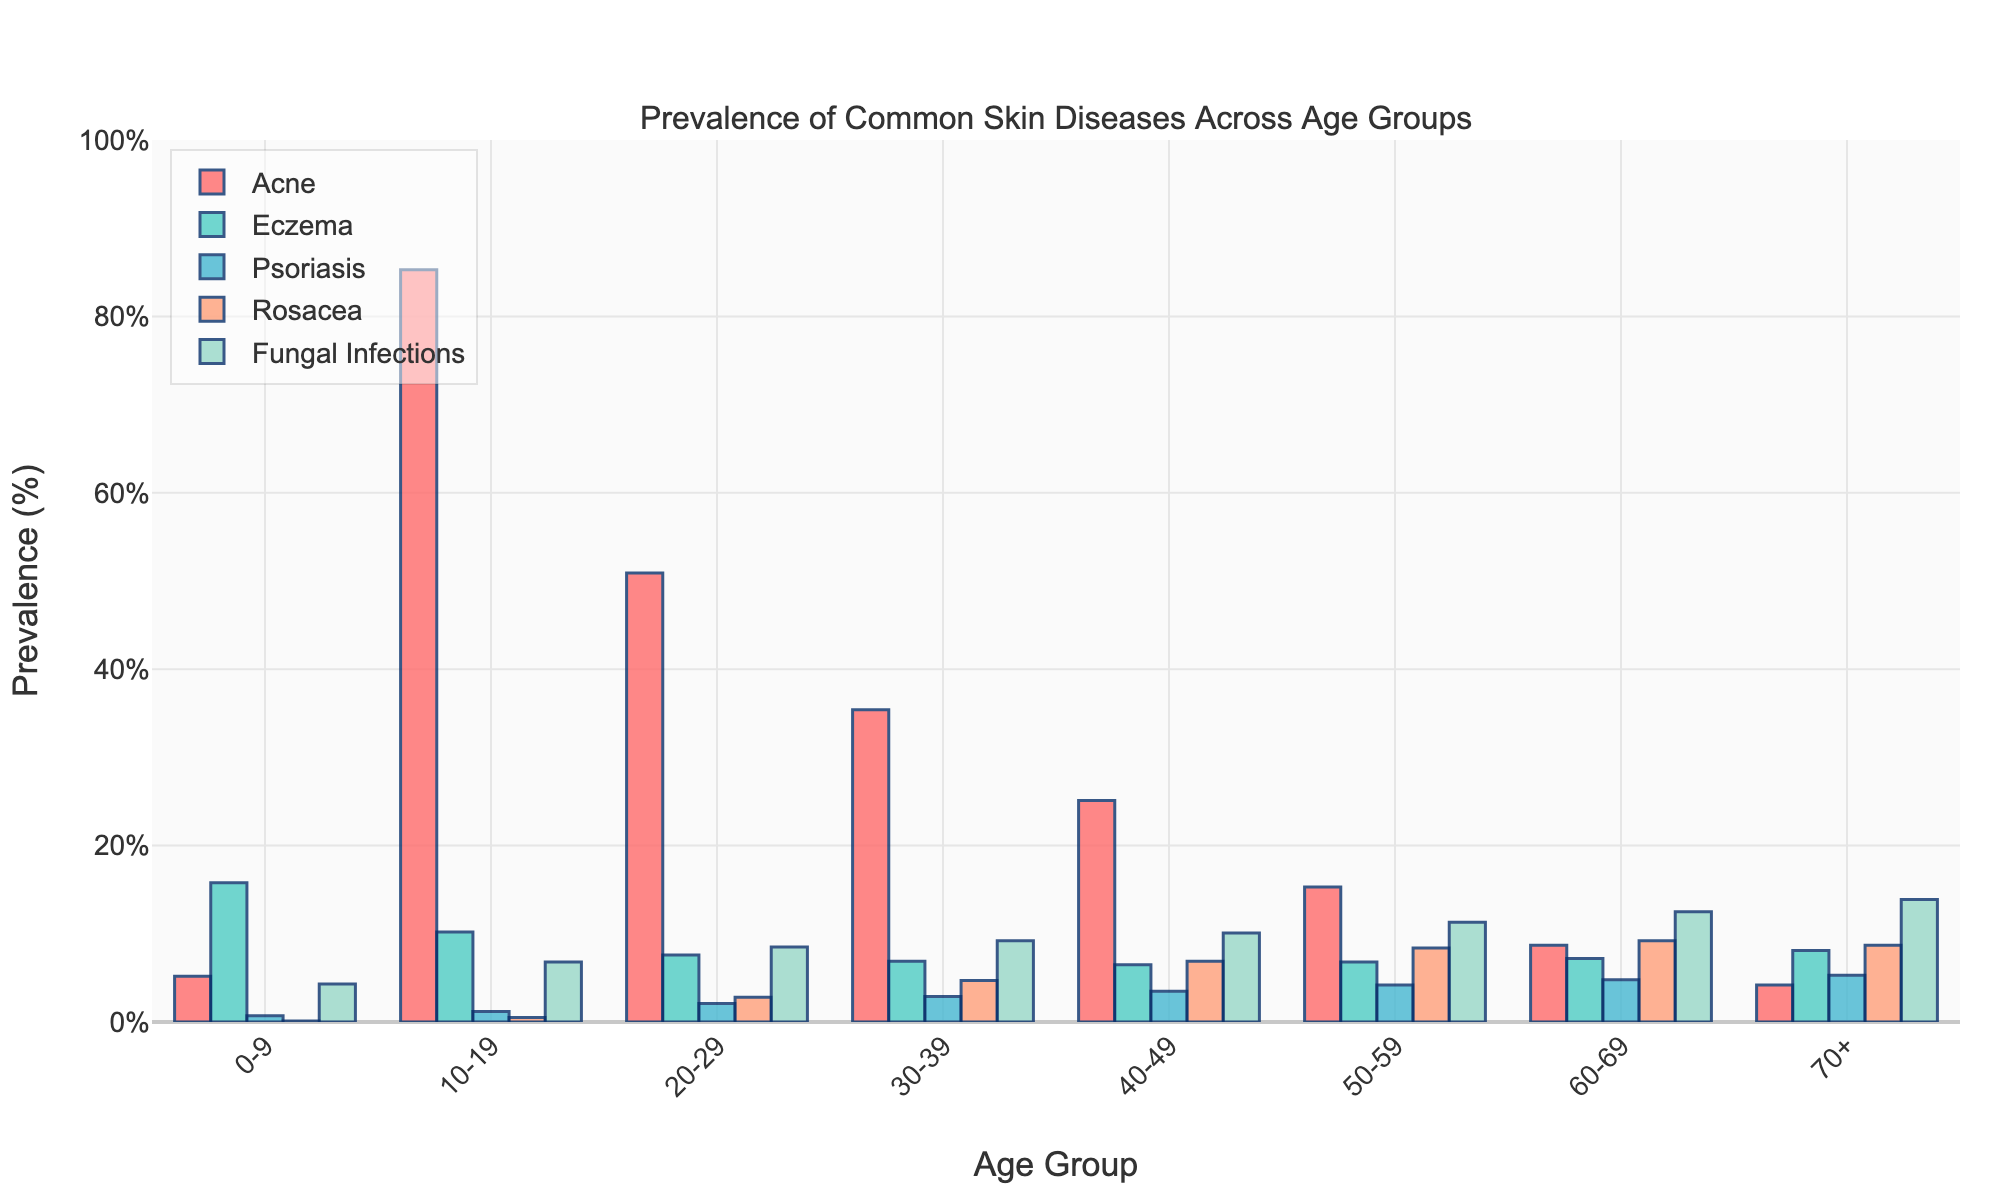Which skin disease is most prevalent among the 10-19 age group? The highest bar in the 10-19 age group corresponds to Acne. Thus, Acne is the most prevalent skin disease in this age group.
Answer: Acne Which age group has the highest prevalence of Rosacea? The bar for Rosacea is highest in the 60-69 age group, compared to other age groups.
Answer: 60-69 What is the difference in prevalence of Eczema between the 0-9 and 70+ age groups? The prevalence of Eczema in the 0-9 age group is 15.8%. In the 70+ age group, it is 8.1%. The difference is calculated as 15.8% - 8.1%.
Answer: 7.7% Among the 50-59 age group, which skin disease has the second highest prevalence? In the 50-59 age group, the bars' heights show that Fungal Infections have the highest prevalence, followed by Rosacea.
Answer: Rosacea What is the average prevalence of Acne across all age groups? First, add the prevalence of Acne across all age groups: 5.2 + 85.3 + 50.9 + 35.4 + 25.1 + 15.3 + 8.7 + 4.2. Then, divide this sum by the number of age groups (8).
Answer: 28.76% For the age group 20-29, compare the prevalence of Psoriasis and Fungal Infections. Which is higher? Looking at the bars for the age group 20-29, the prevalence of Psoriasis is 2.1% and for Fungal Infections is 8.5%. Thus, Fungal Infections is higher.
Answer: Fungal Infections What are the two age groups with the lowest prevalence of Acne, and what are their respective prevalences? The age groups with the noticeably shortest bars for Acne are 70+ with 4.2% and 0-9 with 5.2%.
Answer: 70+ (4.2%), 0-9 (5.2%) Which skin disease shows a rising trend in prevalence as age increases? Observing the bars for each age group, Fungal Infections increase steadily, indicating a rising trend.
Answer: Fungal Infections Compare the prevalence of Eczema between the age groups 0-9 and 30-39. How much higher is the prevalence in the 0-9 age group? Eczema is 15.8% in the 0-9 age group and 6.9% in the 30-39 age group. The difference is 15.8% - 6.9%.
Answer: 8.9% 